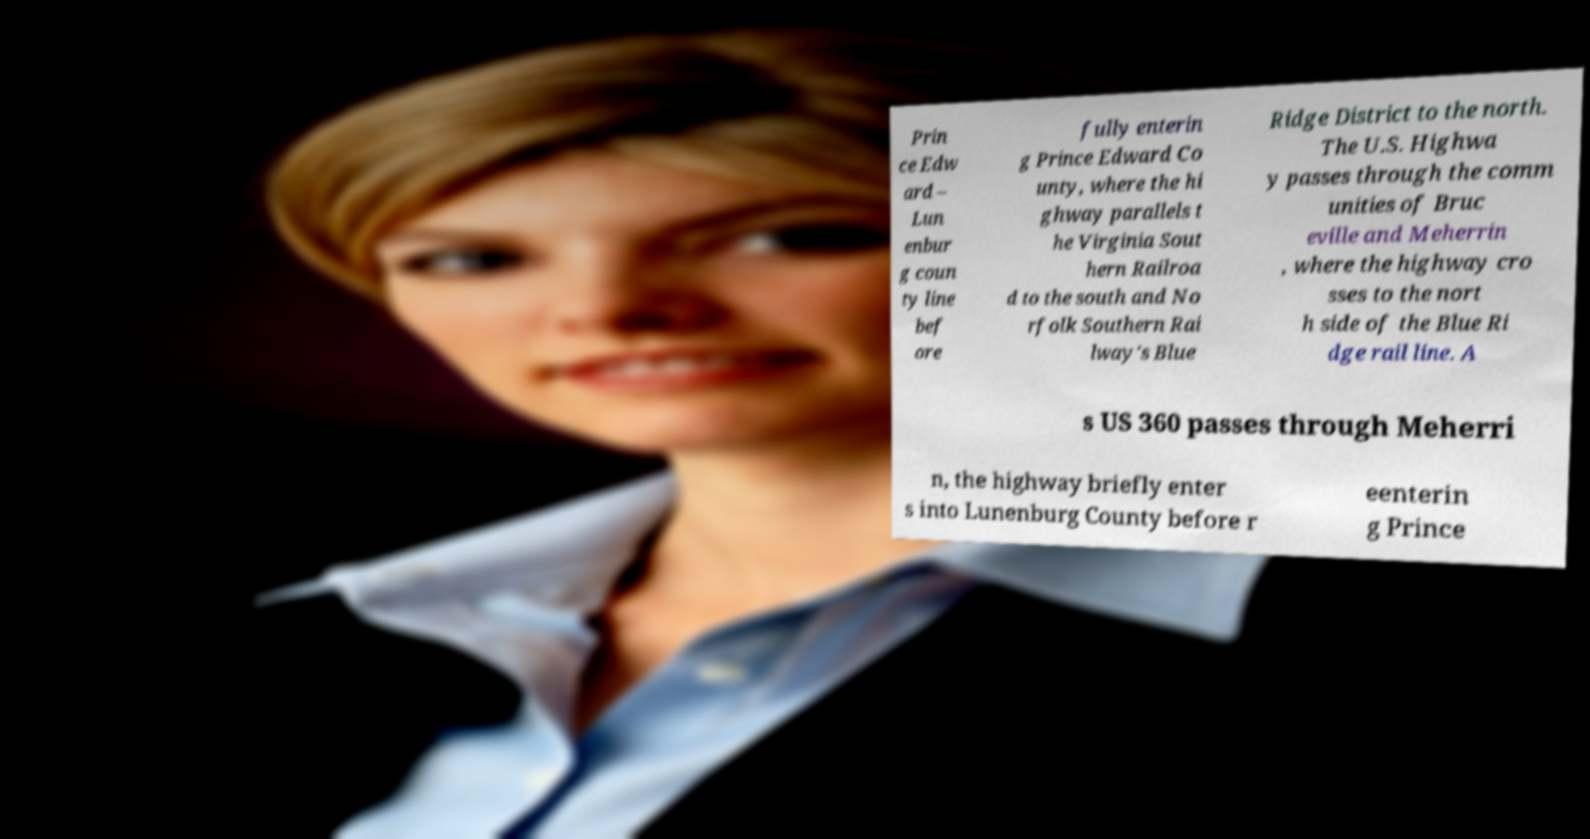For documentation purposes, I need the text within this image transcribed. Could you provide that? Prin ce Edw ard – Lun enbur g coun ty line bef ore fully enterin g Prince Edward Co unty, where the hi ghway parallels t he Virginia Sout hern Railroa d to the south and No rfolk Southern Rai lway's Blue Ridge District to the north. The U.S. Highwa y passes through the comm unities of Bruc eville and Meherrin , where the highway cro sses to the nort h side of the Blue Ri dge rail line. A s US 360 passes through Meherri n, the highway briefly enter s into Lunenburg County before r eenterin g Prince 